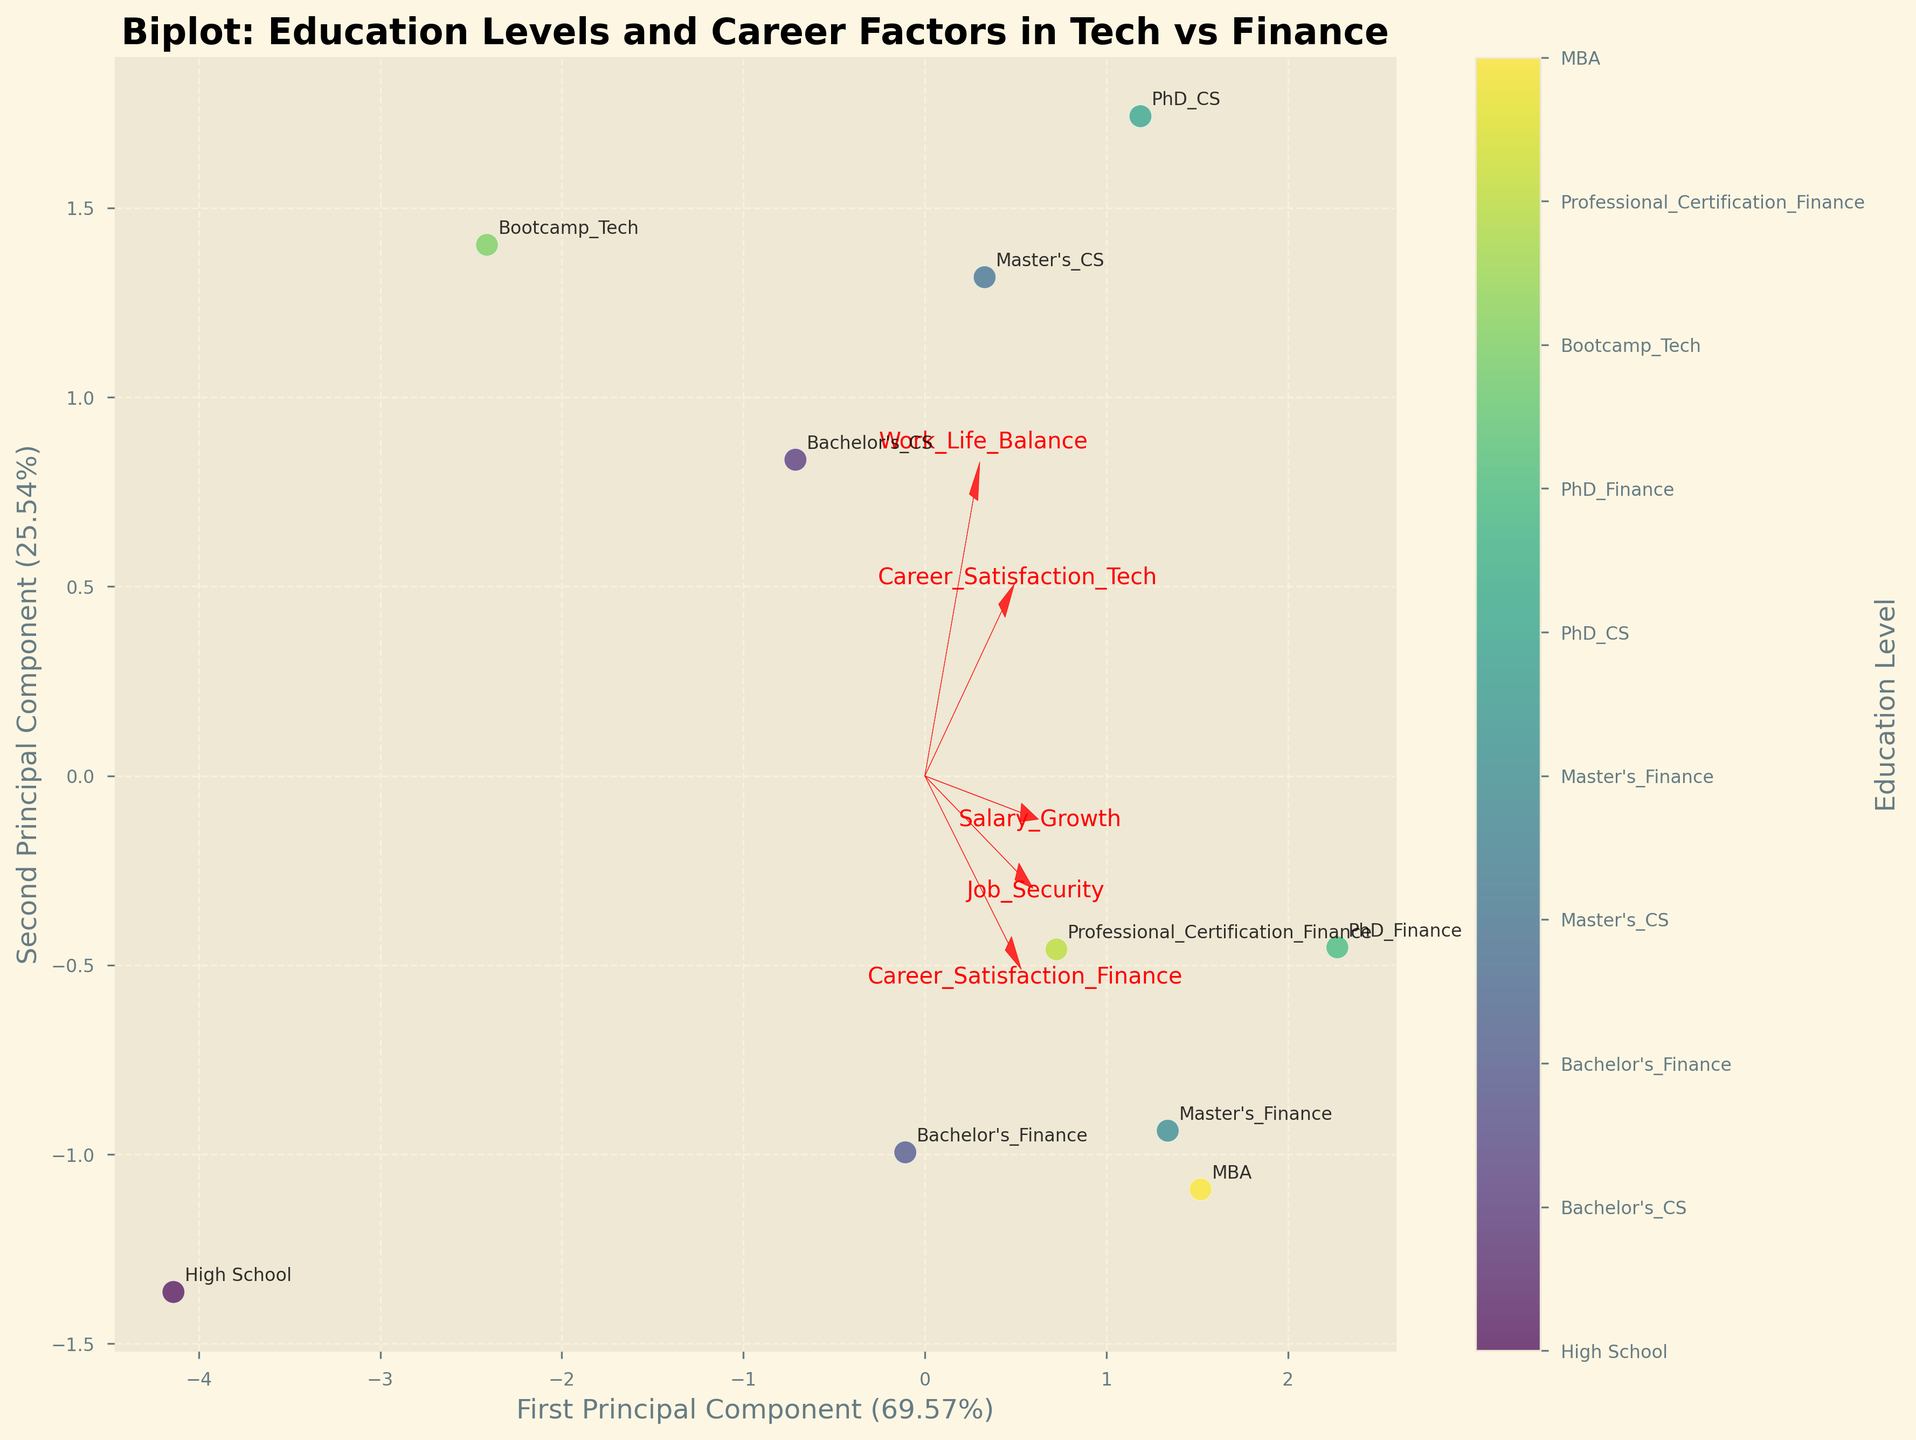What is the title of the plot? The title of the plot is displayed at the top of the biplot and is usually in a larger or bold font for emphasis.
Answer: Biplot: Education Levels and Career Factors in Tech vs Finance How many education levels are represented in the plot? The education levels are indicated by the points on the plot and each point has an annotation corresponding to an education level.
Answer: 10 Which principal component explains more variance in the data? The PCA components' explained variance is typically shown on the axes. The principal component with the higher percentage explains more variance. Here, it's seen on the x-axis and y-axis labels.
Answer: First Principal Component What feature has the most significant influence on the first principal component? In the biplot, the feature vectors (arrows) indicate the direction and magnitude of influence. The length and direction of arrows relative to the first principal component determine significance.
Answer: Career_Satisfaction_Finance Which education level has the highest career satisfaction in finance? Each data point is annotated with an education level and the positions of the points can be compared by looking for the highest value on the axis representing career satisfaction in finance.
Answer: PhD_Finance What is the feature vector for Salary_Growth pointing towards? The feature vectors are shown with arrows and labels. The direction of the Salary_Growth arrow indicates its relationship with the principal components.
Answer: Towards the top-right quadrant How does Master's_CS compare to Master's_Finance in terms of Job_Security and Work_Life_Balance? Look at the positions of Master's_CS and Master's_Finance on the plot and compare their distances along the vectors labeled Job_Security and Work_Life_Balance.
Answer: Master's_Finance is better in both What is the visible relationship between Career_Satisfaction_Tech and Salary_Growth? By observing the direction of the vectors pointing towards Career_Satisfaction_Tech and Salary_Growth, and their angles to each other, we can infer relationships. Large angles indicate weaker or inverse relationships.
Answer: Positive correlation Between high school education and Bootcamp_Tech, which one has better work-life balance? Identify the points annotated with High School and Bootcamp_Tech on the plot, then compare their positions relative to the Work_Life_Balance vector.
Answer: Bootcamp_Tech Which feature has the least influence on the second principal component? By examining the lengths of the feature vectors projected onto the second principal component axis, the shortest vector indicates the least influence.
Answer: Salary_Growth 